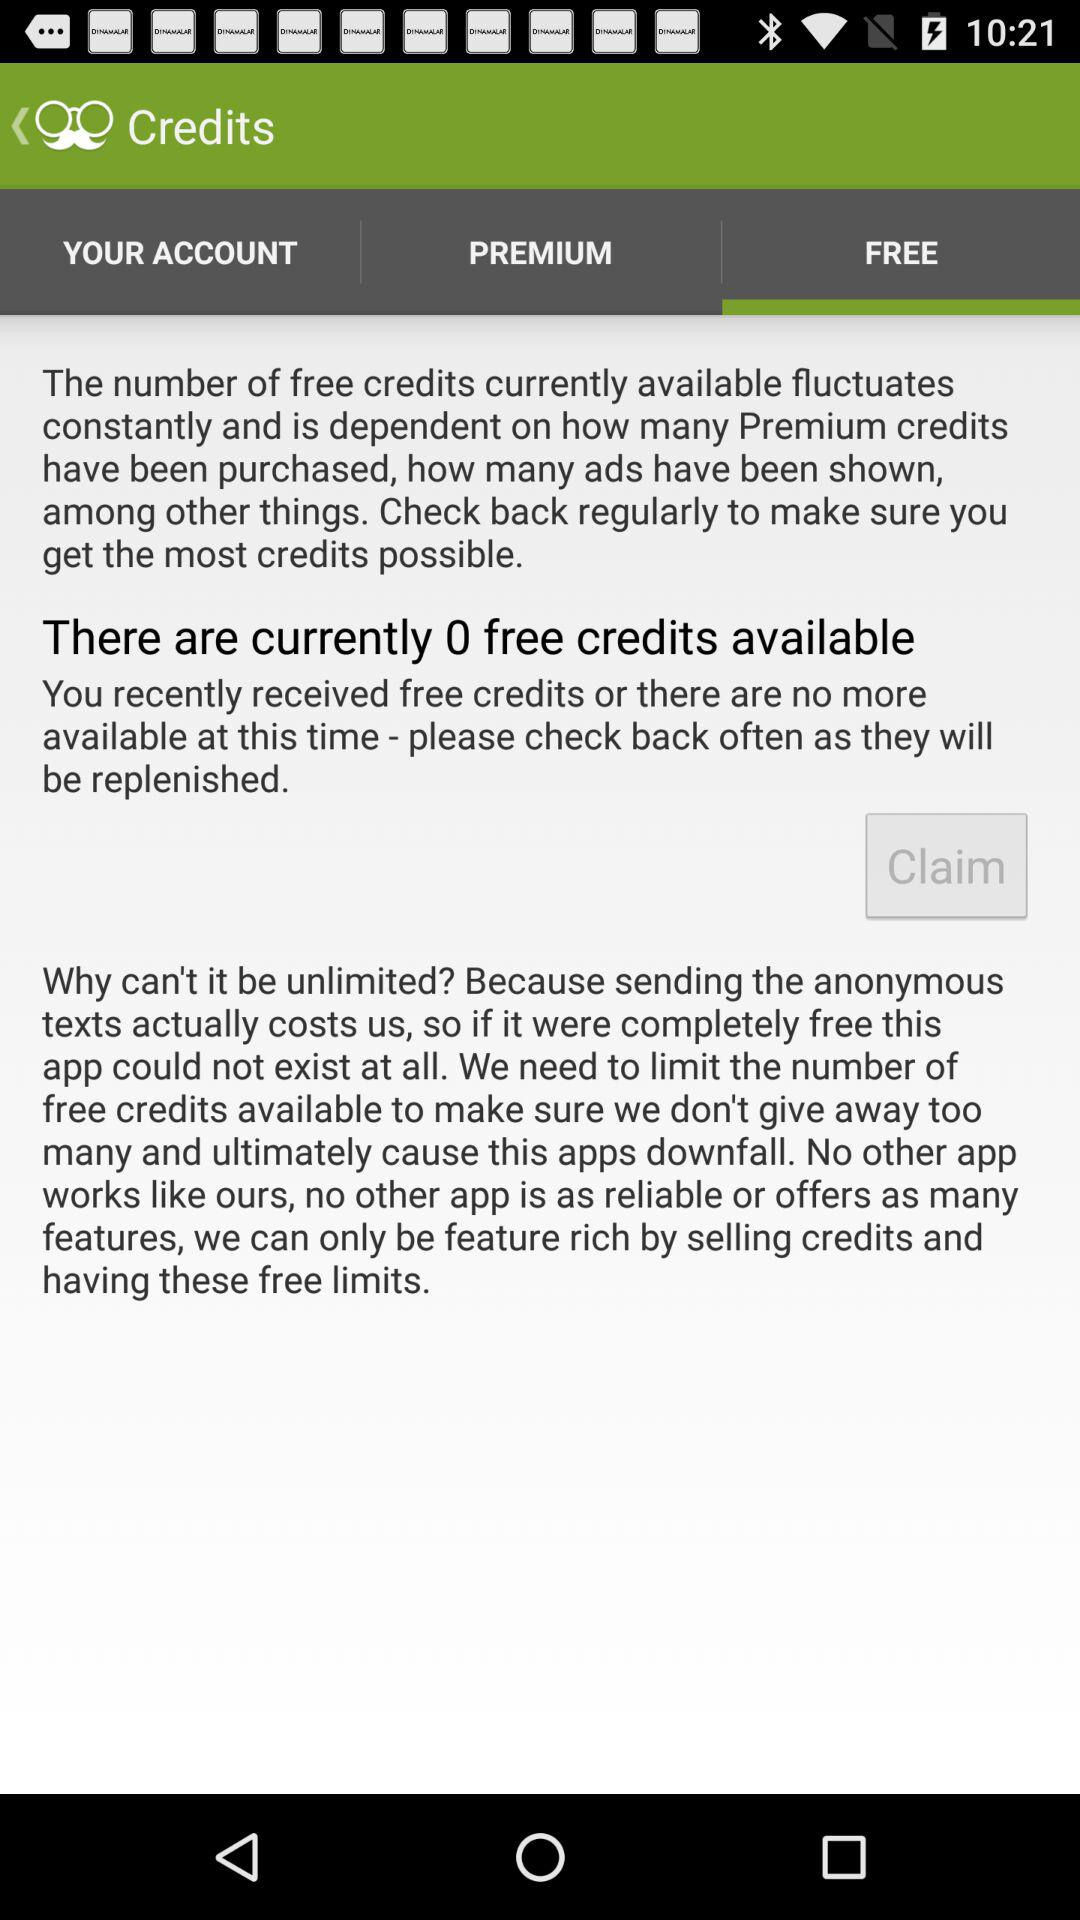Which option is selected? The selected option is "FREE". 